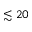<formula> <loc_0><loc_0><loc_500><loc_500>\lesssim 2 0</formula> 